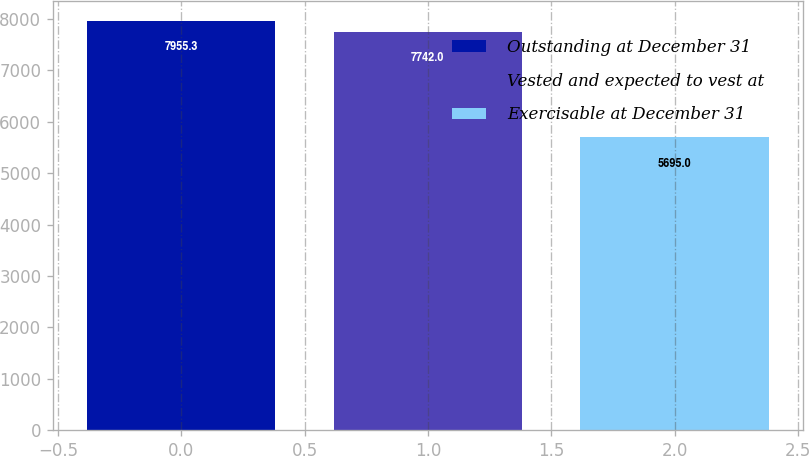<chart> <loc_0><loc_0><loc_500><loc_500><bar_chart><fcel>Outstanding at December 31<fcel>Vested and expected to vest at<fcel>Exercisable at December 31<nl><fcel>7955.3<fcel>7742<fcel>5695<nl></chart> 